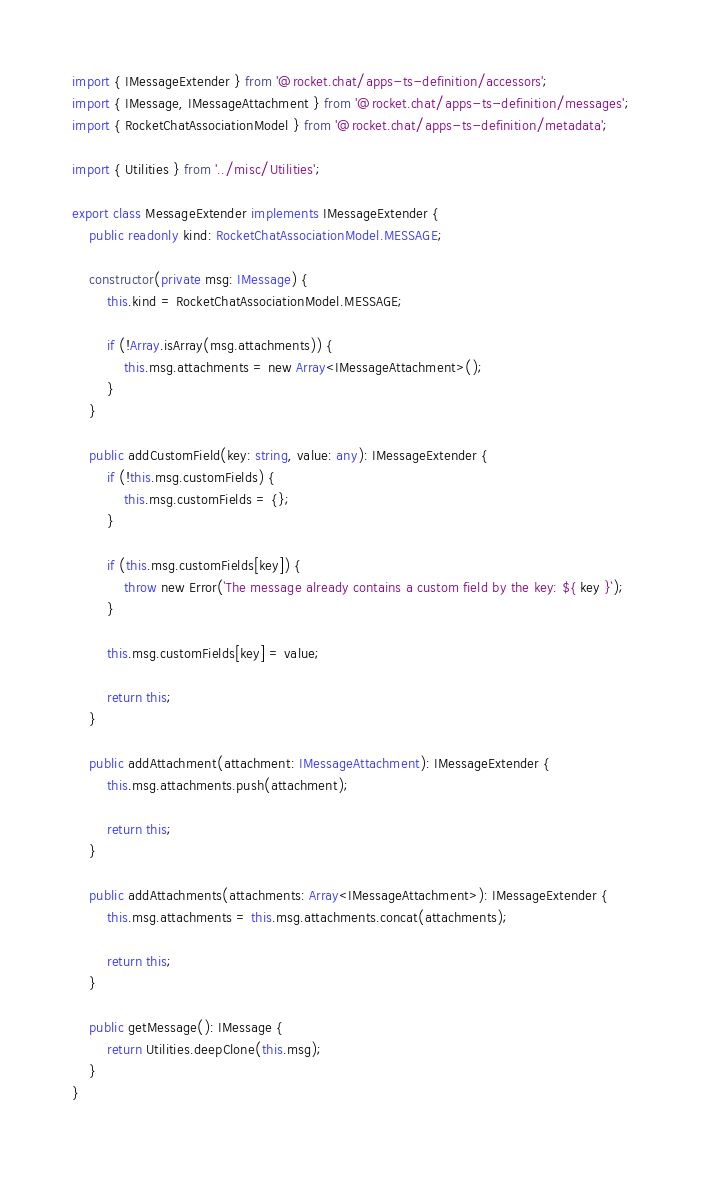Convert code to text. <code><loc_0><loc_0><loc_500><loc_500><_TypeScript_>import { IMessageExtender } from '@rocket.chat/apps-ts-definition/accessors';
import { IMessage, IMessageAttachment } from '@rocket.chat/apps-ts-definition/messages';
import { RocketChatAssociationModel } from '@rocket.chat/apps-ts-definition/metadata';

import { Utilities } from '../misc/Utilities';

export class MessageExtender implements IMessageExtender {
    public readonly kind: RocketChatAssociationModel.MESSAGE;

    constructor(private msg: IMessage) {
        this.kind = RocketChatAssociationModel.MESSAGE;

        if (!Array.isArray(msg.attachments)) {
            this.msg.attachments = new Array<IMessageAttachment>();
        }
    }

    public addCustomField(key: string, value: any): IMessageExtender {
        if (!this.msg.customFields) {
            this.msg.customFields = {};
        }

        if (this.msg.customFields[key]) {
            throw new Error(`The message already contains a custom field by the key: ${ key }`);
        }

        this.msg.customFields[key] = value;

        return this;
    }

    public addAttachment(attachment: IMessageAttachment): IMessageExtender {
        this.msg.attachments.push(attachment);

        return this;
    }

    public addAttachments(attachments: Array<IMessageAttachment>): IMessageExtender {
        this.msg.attachments = this.msg.attachments.concat(attachments);

        return this;
    }

    public getMessage(): IMessage {
        return Utilities.deepClone(this.msg);
    }
}
</code> 